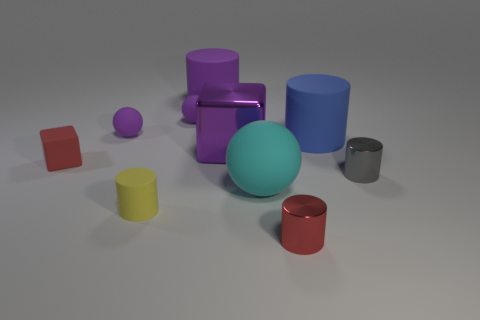Subtract all yellow cylinders. How many cylinders are left? 4 Subtract all gray cylinders. How many cylinders are left? 4 Subtract all yellow cylinders. Subtract all red blocks. How many cylinders are left? 4 Subtract all balls. How many objects are left? 7 Add 9 large purple metallic things. How many large purple metallic things exist? 10 Subtract 1 purple cubes. How many objects are left? 9 Subtract all big purple rubber cylinders. Subtract all big cyan objects. How many objects are left? 8 Add 3 tiny cylinders. How many tiny cylinders are left? 6 